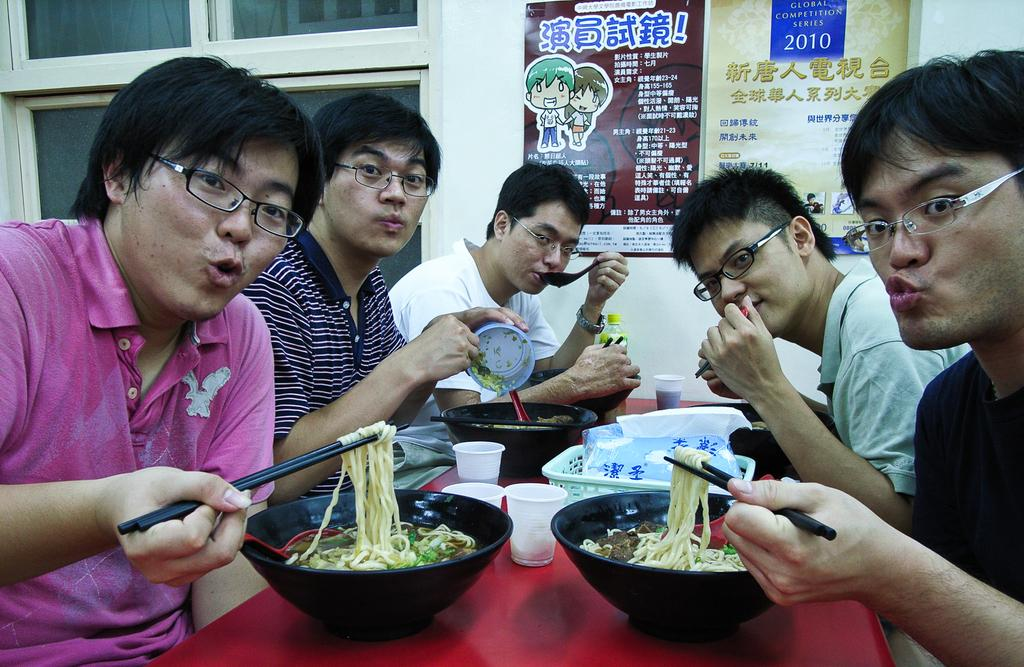What is happening in the image involving the group of people? The people in the image are eating food items. Can you describe the food items being consumed by the group? The provided facts do not specify the type of food being eaten. What else can be seen in the image besides the group of people? There are two posters visible at the top of the image. What type of boats are visible in the image? There are no boats present in the image. What is the texture of the celery being eaten by the group? There is no mention of celery being eaten by the group in the provided facts. 